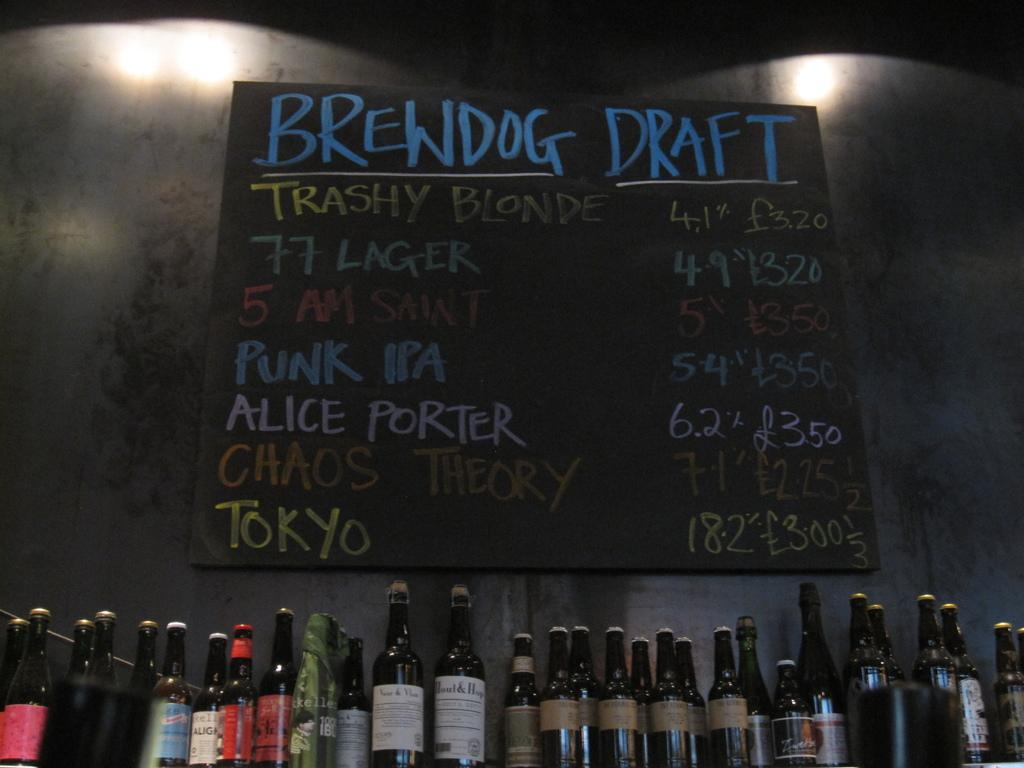<image>
Give a short and clear explanation of the subsequent image. a drink menu that says brewdog draft with their beers under it 